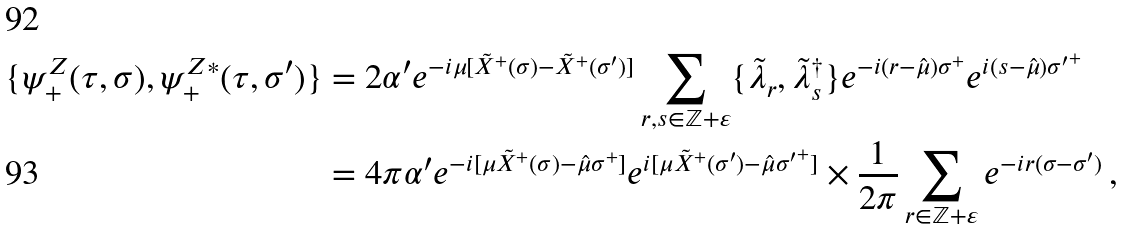Convert formula to latex. <formula><loc_0><loc_0><loc_500><loc_500>\{ \psi ^ { Z } _ { + } ( \tau , \sigma ) , \psi ^ { Z * } _ { + } ( \tau , \sigma ^ { \prime } ) \} & = 2 \alpha ^ { \prime } e ^ { - i \mu [ \tilde { X } ^ { + } ( \sigma ) - \tilde { X } ^ { + } ( \sigma ^ { \prime } ) ] } \sum _ { r , s \in { \mathbb { Z } } + \varepsilon } \{ \tilde { \lambda } _ { r } , \tilde { \lambda } ^ { \dagger } _ { s } \} e ^ { - i ( r - \hat { \mu } ) \sigma ^ { + } } e ^ { i ( s - \hat { \mu } ) { \sigma ^ { \prime } } ^ { + } } \\ & = 4 \pi \alpha ^ { \prime } e ^ { - i [ \mu \tilde { X } ^ { + } ( \sigma ) - \hat { \mu } \sigma ^ { + } ] } e ^ { i [ \mu \tilde { X } ^ { + } ( \sigma ^ { \prime } ) - \hat { \mu } { \sigma ^ { \prime } } ^ { + } ] } \times \frac { 1 } { 2 \pi } \sum _ { r \in { \mathbb { Z } } + \varepsilon } e ^ { - i r ( \sigma - \sigma ^ { \prime } ) } \, ,</formula> 